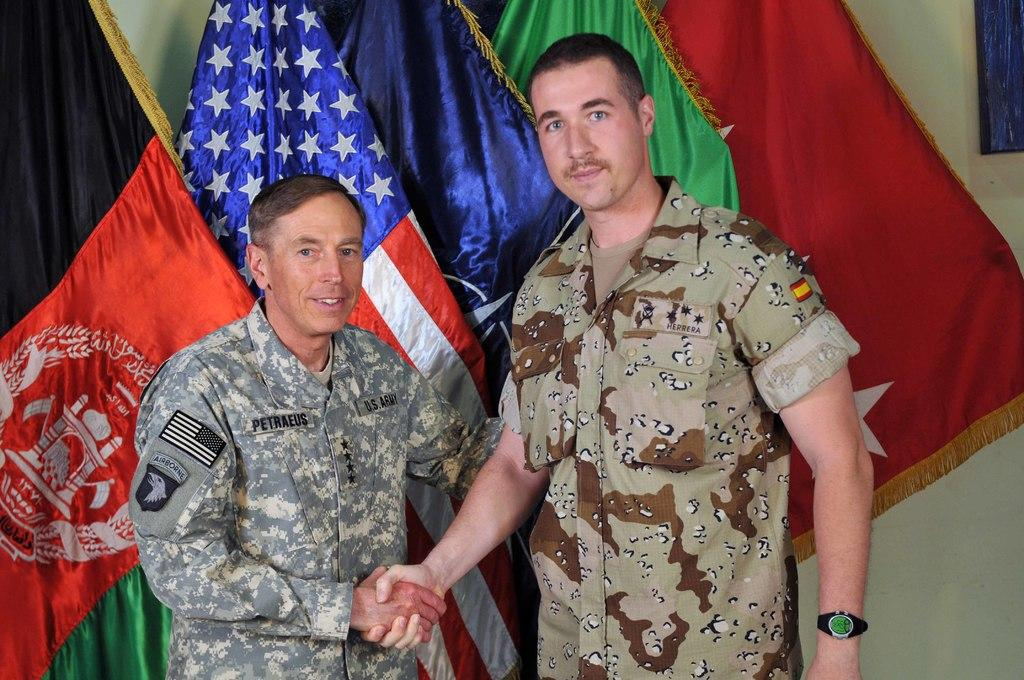<image>
Share a concise interpretation of the image provided. Petraeus shakes hands with a man whose sleeves are rolled up. 